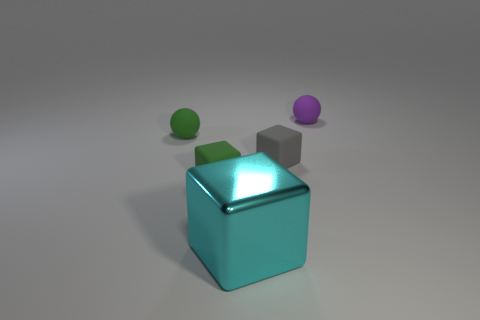Subtract all purple cubes. Subtract all green balls. How many cubes are left? 3 Subtract all gray balls. How many red blocks are left? 0 Add 2 big objects. How many small grays exist? 0 Subtract all small gray objects. Subtract all green matte cubes. How many objects are left? 3 Add 2 tiny gray rubber things. How many tiny gray rubber things are left? 3 Add 4 big cyan shiny things. How many big cyan shiny things exist? 5 Add 5 small yellow metallic balls. How many objects exist? 10 Subtract all gray blocks. How many blocks are left? 2 Subtract all cyan blocks. How many blocks are left? 2 Subtract 0 green cylinders. How many objects are left? 5 